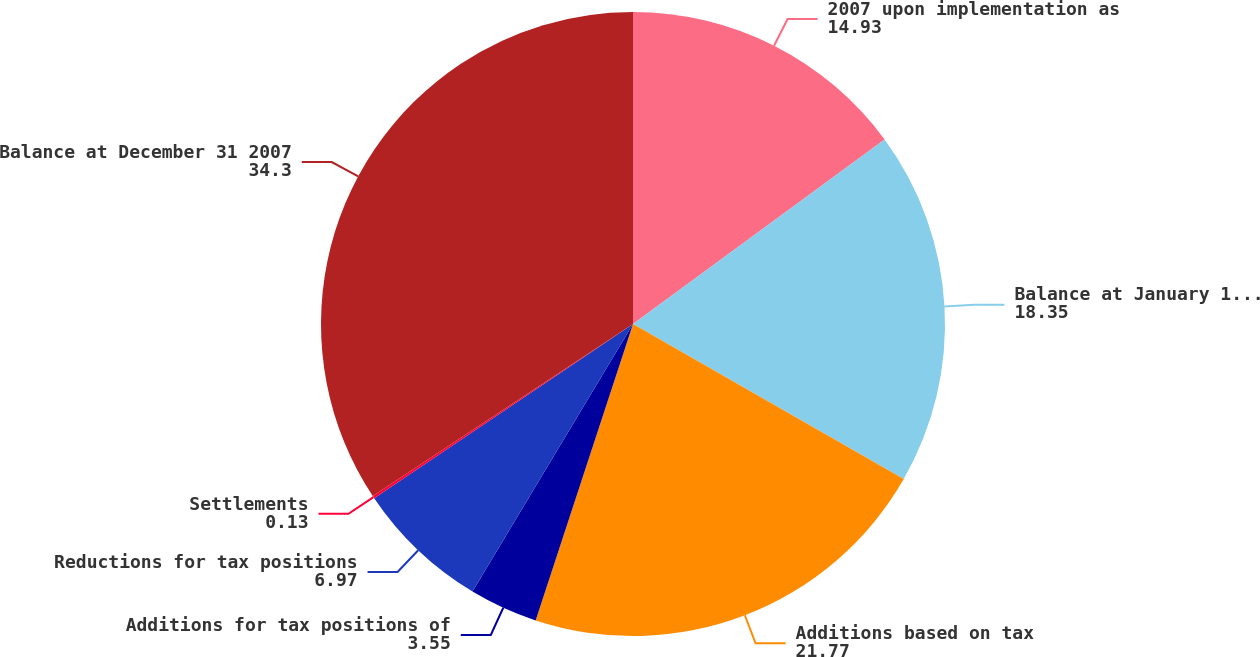Convert chart to OTSL. <chart><loc_0><loc_0><loc_500><loc_500><pie_chart><fcel>2007 upon implementation as<fcel>Balance at January 1 2007<fcel>Additions based on tax<fcel>Additions for tax positions of<fcel>Reductions for tax positions<fcel>Settlements<fcel>Balance at December 31 2007<nl><fcel>14.93%<fcel>18.35%<fcel>21.77%<fcel>3.55%<fcel>6.97%<fcel>0.13%<fcel>34.3%<nl></chart> 